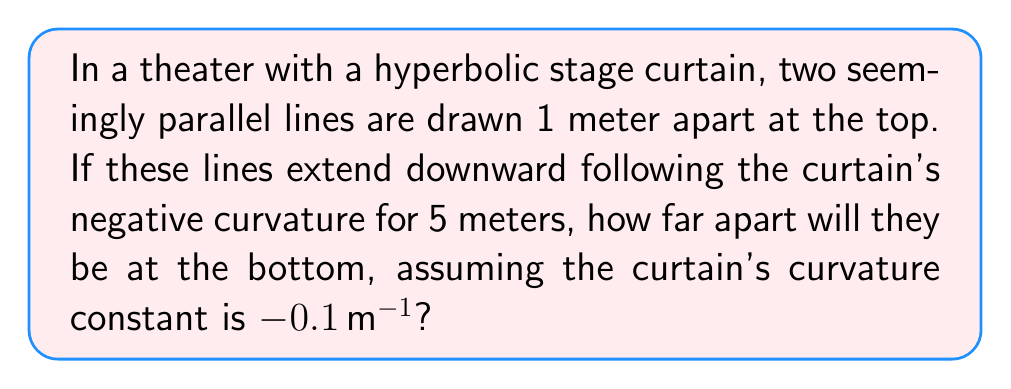Can you solve this math problem? Let's approach this step-by-step:

1) In hyperbolic geometry (negative curvature), parallel lines diverge. The distance between them increases exponentially with the distance traveled.

2) The formula for the distance between two initially parallel lines on a surface with constant negative curvature is:

   $$d(t) = d_0 e^{\sqrt{-K}t}$$

   Where:
   $d(t)$ is the distance after traveling $t$ meters
   $d_0$ is the initial distance
   $K$ is the curvature constant
   $t$ is the distance traveled

3) Given:
   $d_0 = 1$ m (initial distance)
   $K = -0.1$ m^(-1) (curvature constant)
   $t = 5$ m (distance traveled)

4) Substituting these values into our formula:

   $$d(5) = 1 \cdot e^{\sqrt{0.1} \cdot 5}$$

5) Simplify:
   $$d(5) = e^{\sqrt{0.1} \cdot 5} \approx e^{1.581139}$$

6) Calculate:
   $$d(5) \approx 4.86 \text{ m}$$

Thus, after traveling 5 meters down the curtain, the lines will be approximately 4.86 meters apart.
Answer: 4.86 meters 